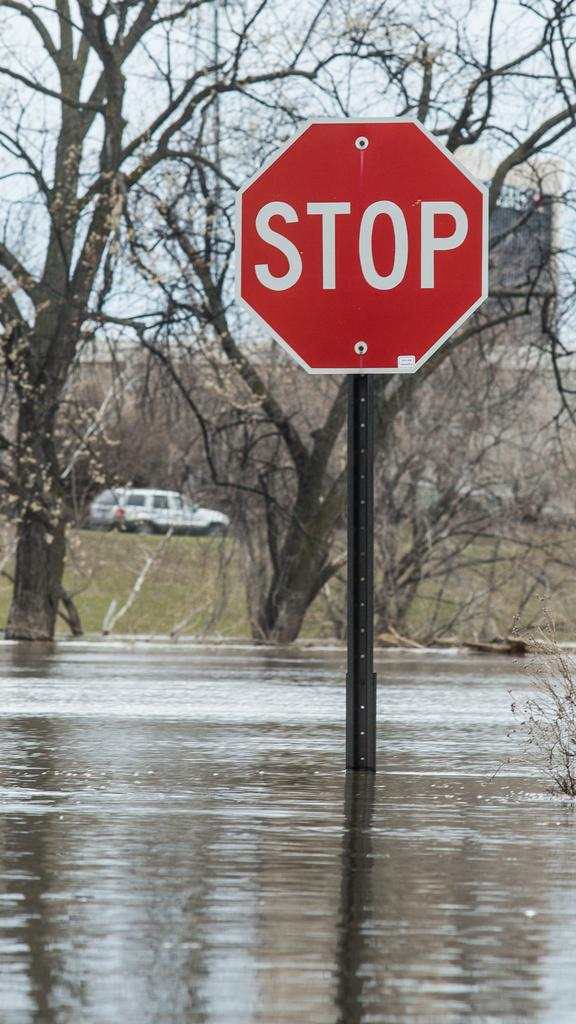<image>
Relay a brief, clear account of the picture shown. A stop sign in a flooded area and a white SUV in the background. 